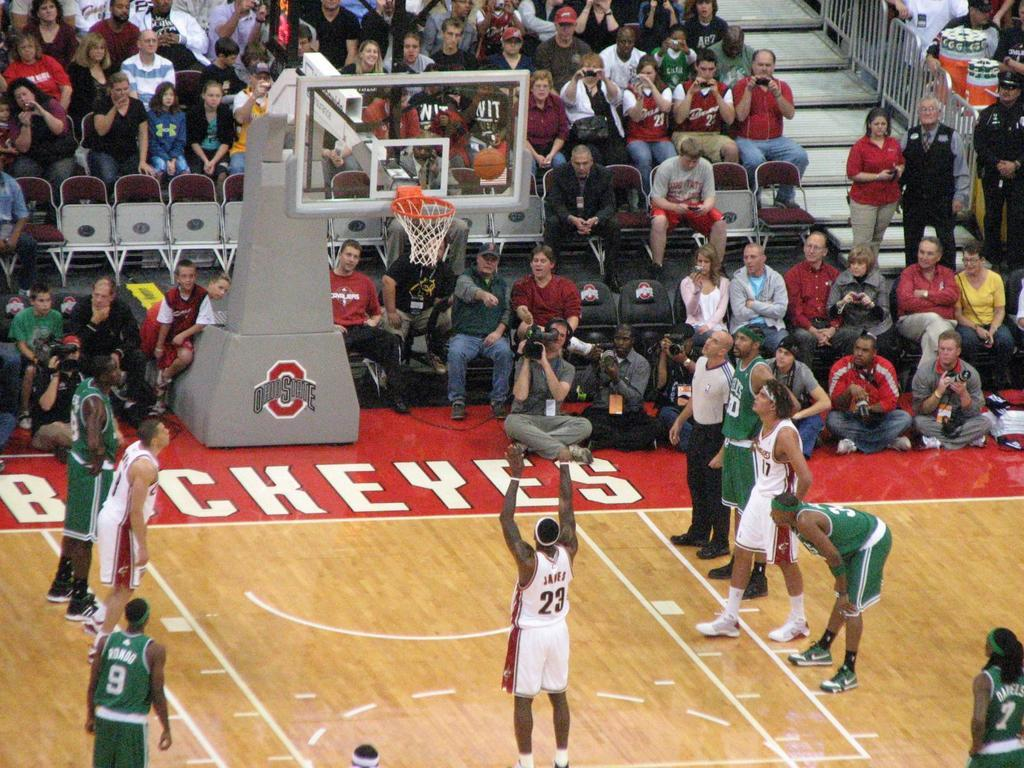Provide a one-sentence caption for the provided image. Two teams play one another on an Ohio State Buckeyes basketball court. 